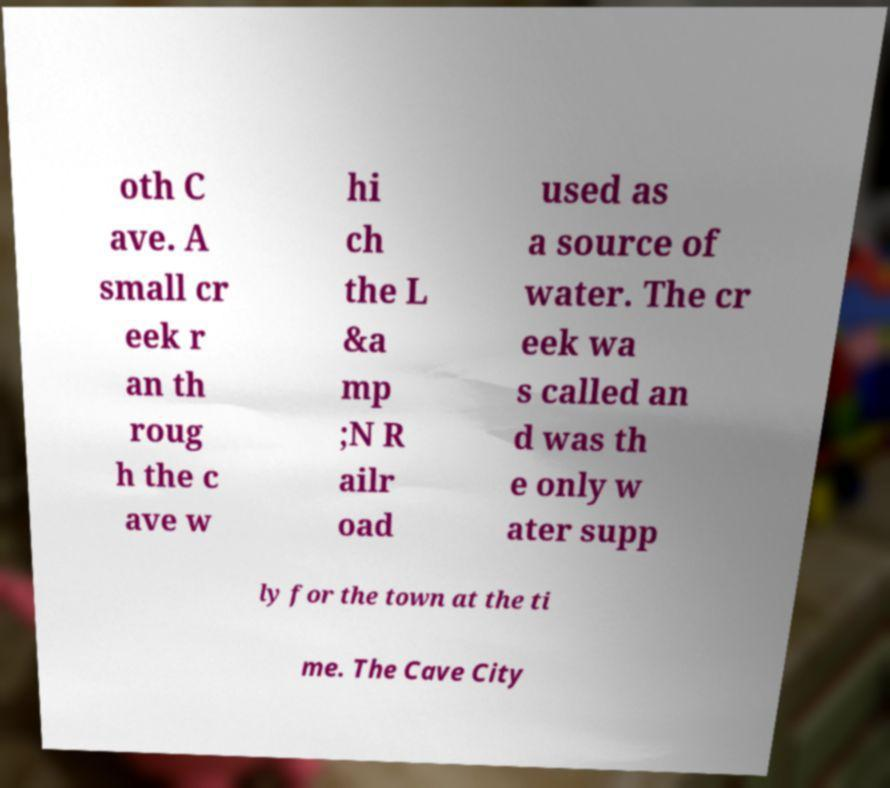Can you read and provide the text displayed in the image?This photo seems to have some interesting text. Can you extract and type it out for me? oth C ave. A small cr eek r an th roug h the c ave w hi ch the L &a mp ;N R ailr oad used as a source of water. The cr eek wa s called an d was th e only w ater supp ly for the town at the ti me. The Cave City 